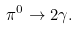Convert formula to latex. <formula><loc_0><loc_0><loc_500><loc_500>\pi ^ { 0 } \rightarrow 2 \gamma .</formula> 